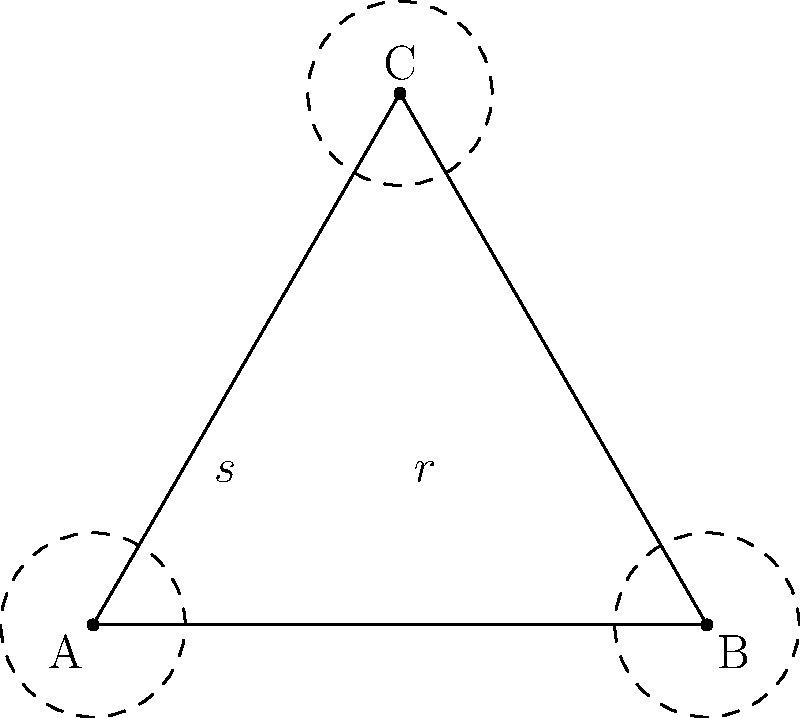A triangular car air freshener has the shape of an equilateral triangle. Consider the dihedral group $D_3$ of symmetries of this triangle. If $r$ represents a 120° rotation clockwise and $s$ represents a reflection across the altitude from vertex C, what is the result of the composition $rs$? Let's approach this step-by-step:

1) First, recall that in group theory, we apply operations from right to left. So $rs$ means we first apply $s$, then $r$.

2) The reflection $s$ flips the triangle across the altitude from C:
   - A moves to B
   - B moves to A
   - C stays fixed

3) After applying $s$, we then rotate by 120° clockwise ($r$):
   - The point that was at A (now at B) moves to C
   - The point that was at B (now at A) moves to B
   - The point that was at C (which stayed at C after reflection) moves to A

4) The overall effect:
   - A ends up at B
   - B ends up at C
   - C ends up at A

5) This is equivalent to a 120° counterclockwise rotation, which we can denote as $r^2$ (since $r^3 = e$, the identity).

Therefore, $rs = r^2$.
Answer: $r^2$ 